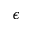<formula> <loc_0><loc_0><loc_500><loc_500>\epsilon</formula> 